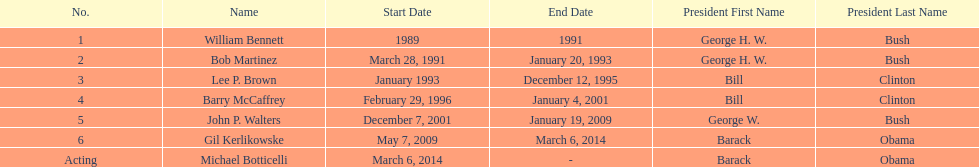How many directors served more than 3 years? 3. 